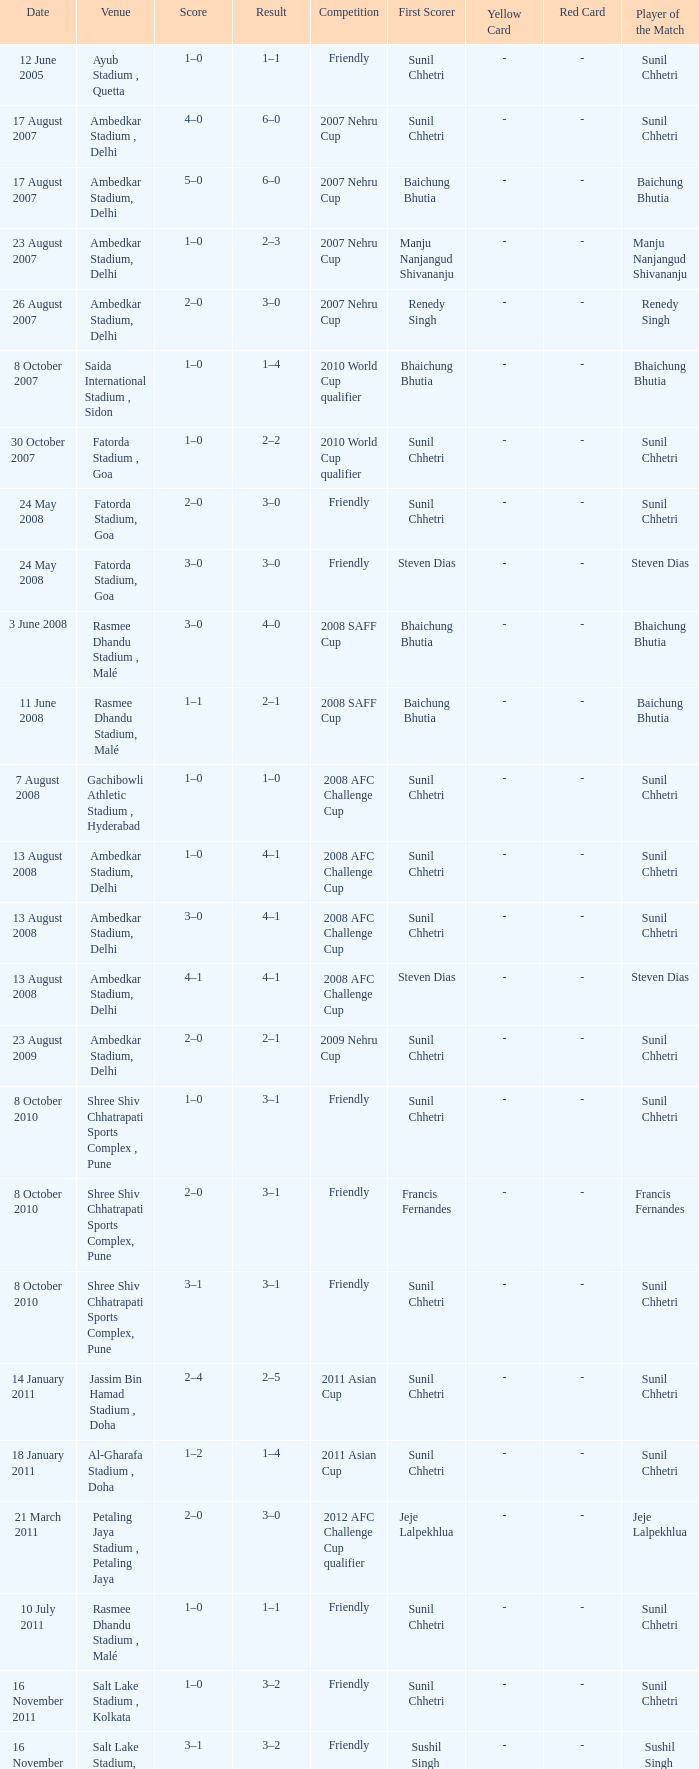Tell me the score on 22 august 2012 1–0. 